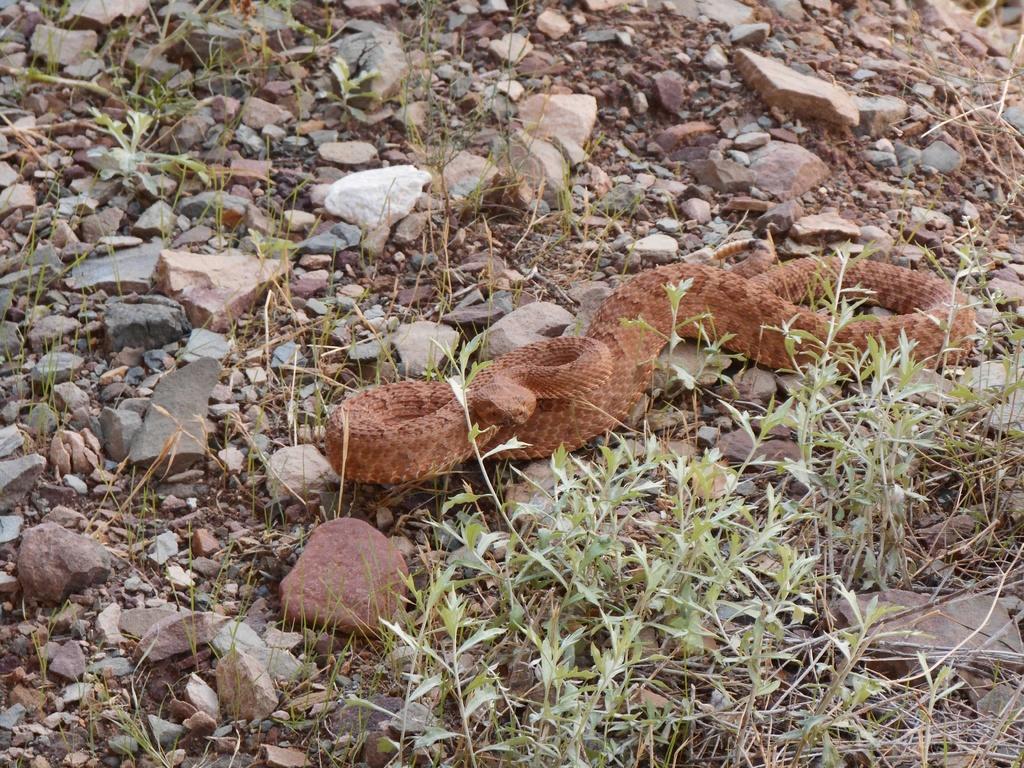Could you give a brief overview of what you see in this image? In this picture I can see there is a snake here and there are stones, rocks, plants, soil on the ground. 